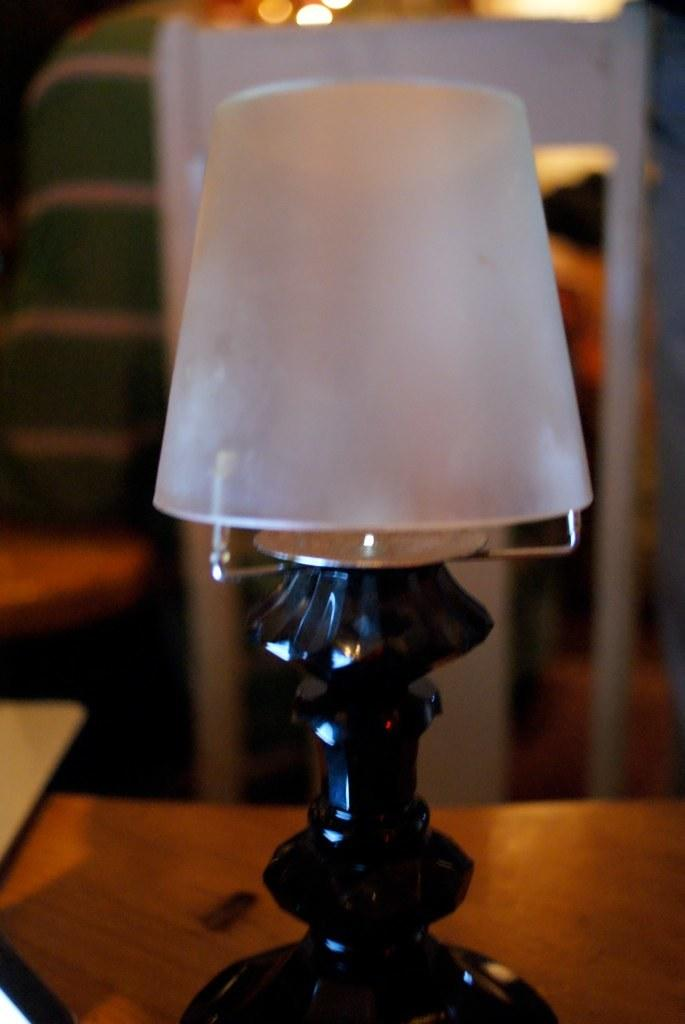What object can be seen in the image? There is a lamp in the image. What color is the lamp? The lamp is in black and white color. What is the lamp placed on? The lamp is on a brown table. Can you describe the background of the image? The background of the image is blurred. What type of payment is being made in the image? There is no payment being made in the image; it features a black and white lamp on a brown table with a blurred background. 